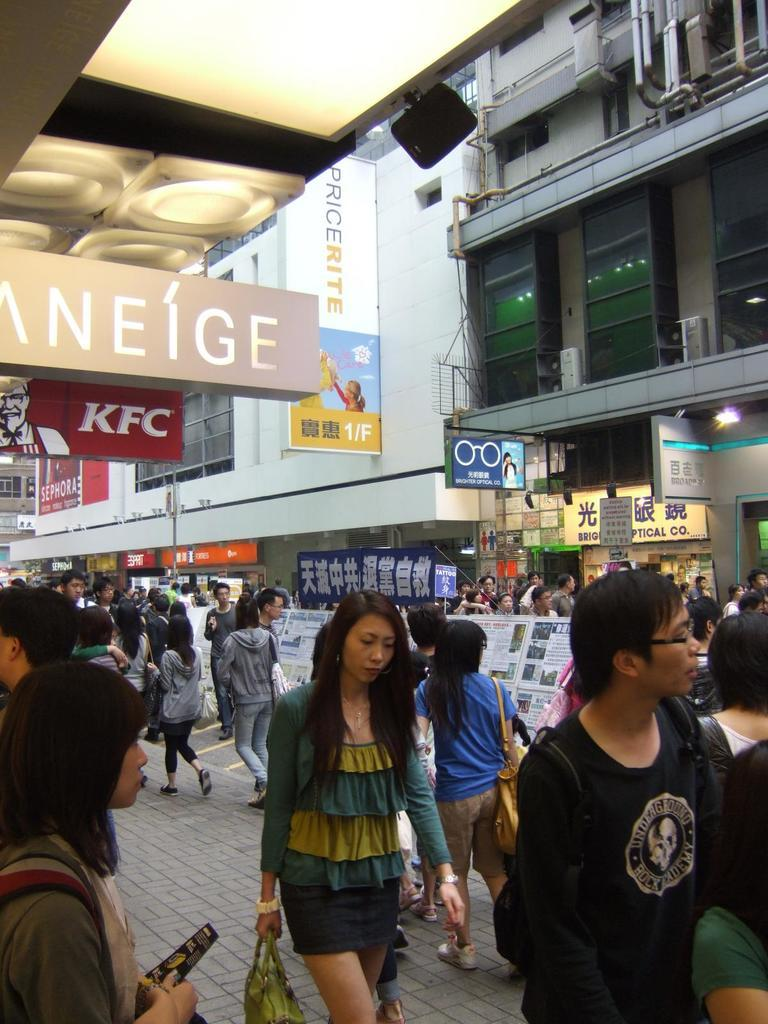What are the people in the image doing? The people in the image are walking on a path. What can be seen in the background of the image? There are buildings in the background of the image. What is attached to the buildings? There are banners on the buildings. What is written on the banners? There is text on the banners. Can you tell me how many robins are sitting on the banners in the image? There are no robins present in the image; it only features people walking, buildings, banners, and text. 